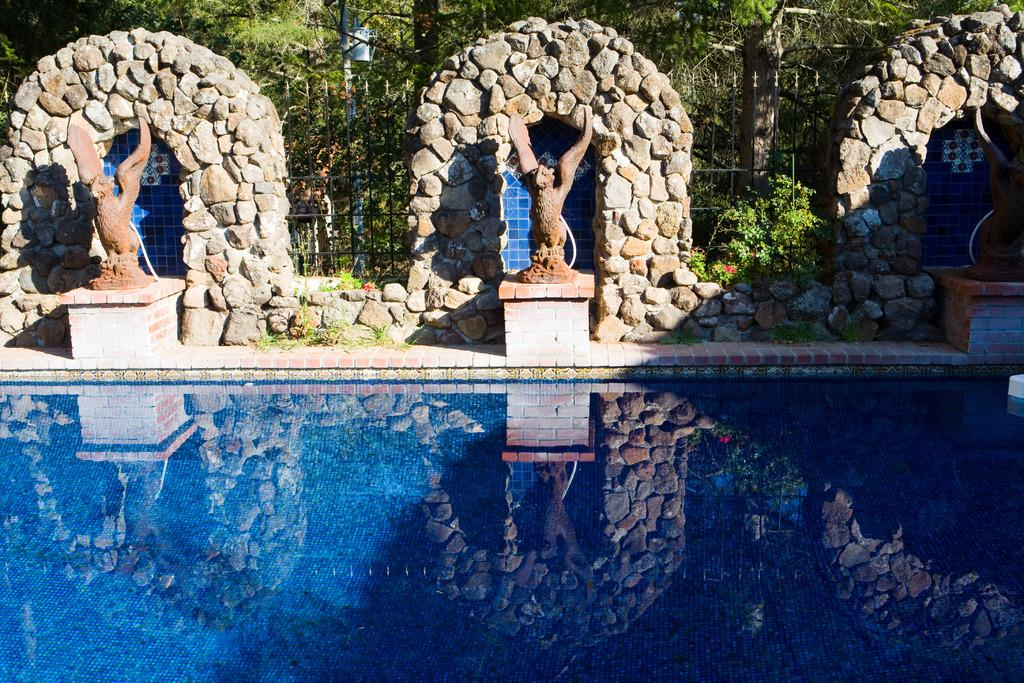What is the main feature in the image? There is a swimming pool in the image. What can be seen behind the swimming pool? There are sculptures behind the pool. What type of natural structures are visible behind the sculptures? Rock arches are visible behind the sculptures. What type of barrier is present in the image? A metal rod fence is present in the image. What type of vegetation is present in the image? Plants and trees are present in the image. What type of duck can be seen swimming in the pool? There is no duck present in the image; it features a swimming pool with sculptures, rock arches, a metal rod fence, and vegetation. What type of flesh can be seen hanging from the rock arches? There is no flesh present in the image; it features a swimming pool, sculptures, rock arches, a metal rod fence, and vegetation. 